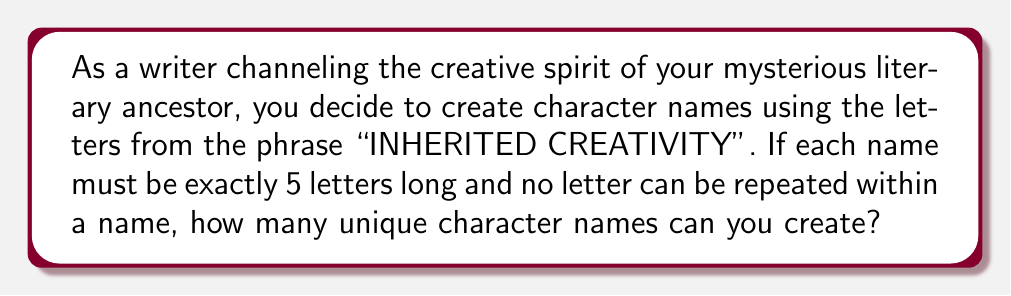What is the answer to this math problem? Let's approach this step-by-step:

1. First, let's identify the unique letters in "INHERITED CREATIVITY":
   I, N, H, E, R, T, D, C, A, V, Y
   There are 11 unique letters.

2. This is a permutation problem. We need to choose 5 letters out of 11, where order matters and repetition is not allowed.

3. The formula for this type of permutation is:
   $P(n,r) = \frac{n!}{(n-r)!}$
   Where $n$ is the total number of items to choose from, and $r$ is the number of items being chosen.

4. In this case, $n = 11$ (total unique letters) and $r = 5$ (length of each name).

5. Plugging these values into the formula:
   $$P(11,5) = \frac{11!}{(11-5)!} = \frac{11!}{6!}$$

6. Expanding this:
   $$\frac{11 \times 10 \times 9 \times 8 \times 7 \times 6!}{6!}$$

7. The $6!$ cancels out in the numerator and denominator:
   $$11 \times 10 \times 9 \times 8 \times 7 = 55,440$$

Therefore, you can create 55,440 unique character names using the given constraints.
Answer: 55,440 